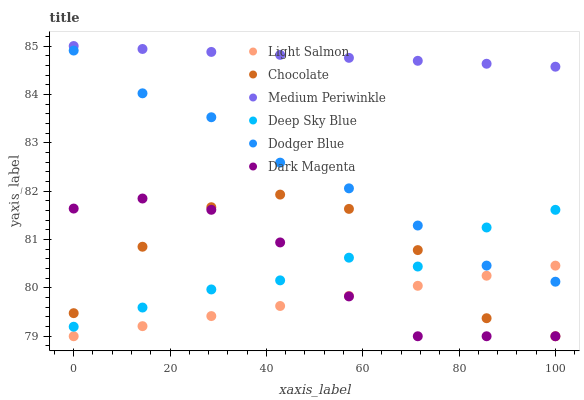Does Light Salmon have the minimum area under the curve?
Answer yes or no. Yes. Does Medium Periwinkle have the maximum area under the curve?
Answer yes or no. Yes. Does Dark Magenta have the minimum area under the curve?
Answer yes or no. No. Does Dark Magenta have the maximum area under the curve?
Answer yes or no. No. Is Light Salmon the smoothest?
Answer yes or no. Yes. Is Chocolate the roughest?
Answer yes or no. Yes. Is Dark Magenta the smoothest?
Answer yes or no. No. Is Dark Magenta the roughest?
Answer yes or no. No. Does Light Salmon have the lowest value?
Answer yes or no. Yes. Does Medium Periwinkle have the lowest value?
Answer yes or no. No. Does Medium Periwinkle have the highest value?
Answer yes or no. Yes. Does Dark Magenta have the highest value?
Answer yes or no. No. Is Deep Sky Blue less than Medium Periwinkle?
Answer yes or no. Yes. Is Deep Sky Blue greater than Light Salmon?
Answer yes or no. Yes. Does Light Salmon intersect Chocolate?
Answer yes or no. Yes. Is Light Salmon less than Chocolate?
Answer yes or no. No. Is Light Salmon greater than Chocolate?
Answer yes or no. No. Does Deep Sky Blue intersect Medium Periwinkle?
Answer yes or no. No. 